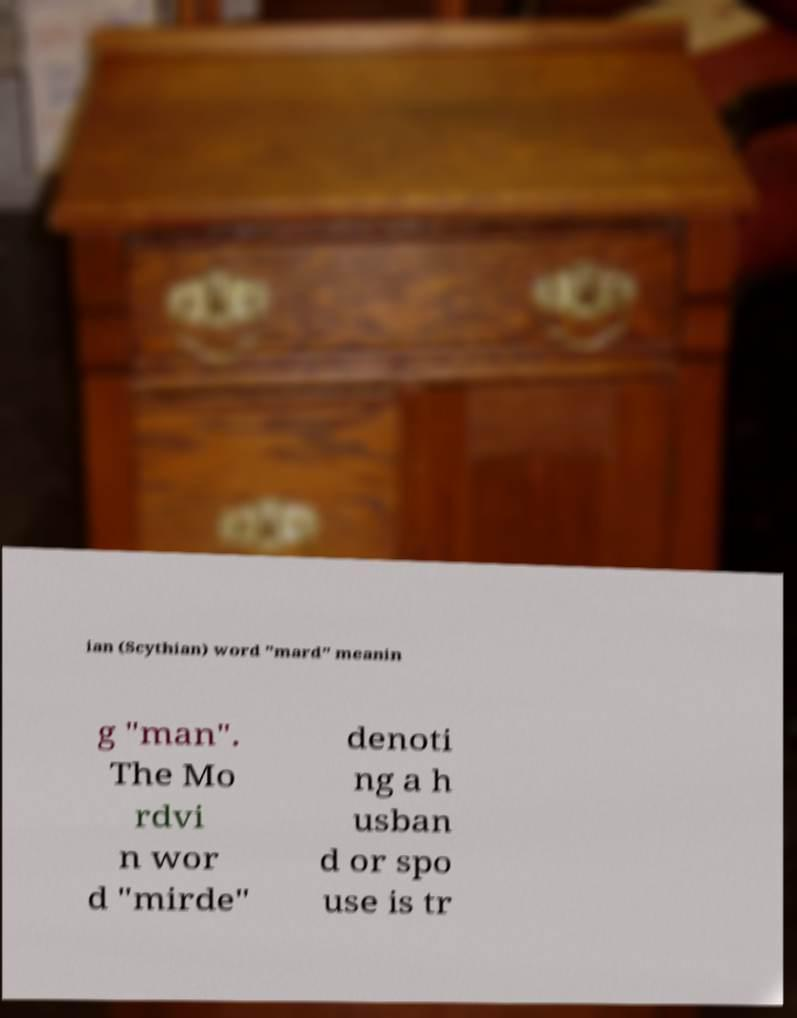There's text embedded in this image that I need extracted. Can you transcribe it verbatim? ian (Scythian) word "mard" meanin g "man". The Mo rdvi n wor d "mirde" denoti ng a h usban d or spo use is tr 